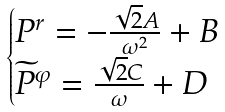<formula> <loc_0><loc_0><loc_500><loc_500>\begin{cases} P ^ { r } = - \frac { \sqrt { 2 } A } { \omega ^ { 2 } } + B \\ \widetilde { P } ^ { \varphi } = \frac { \sqrt { 2 } C } { \omega } + D \end{cases}</formula> 